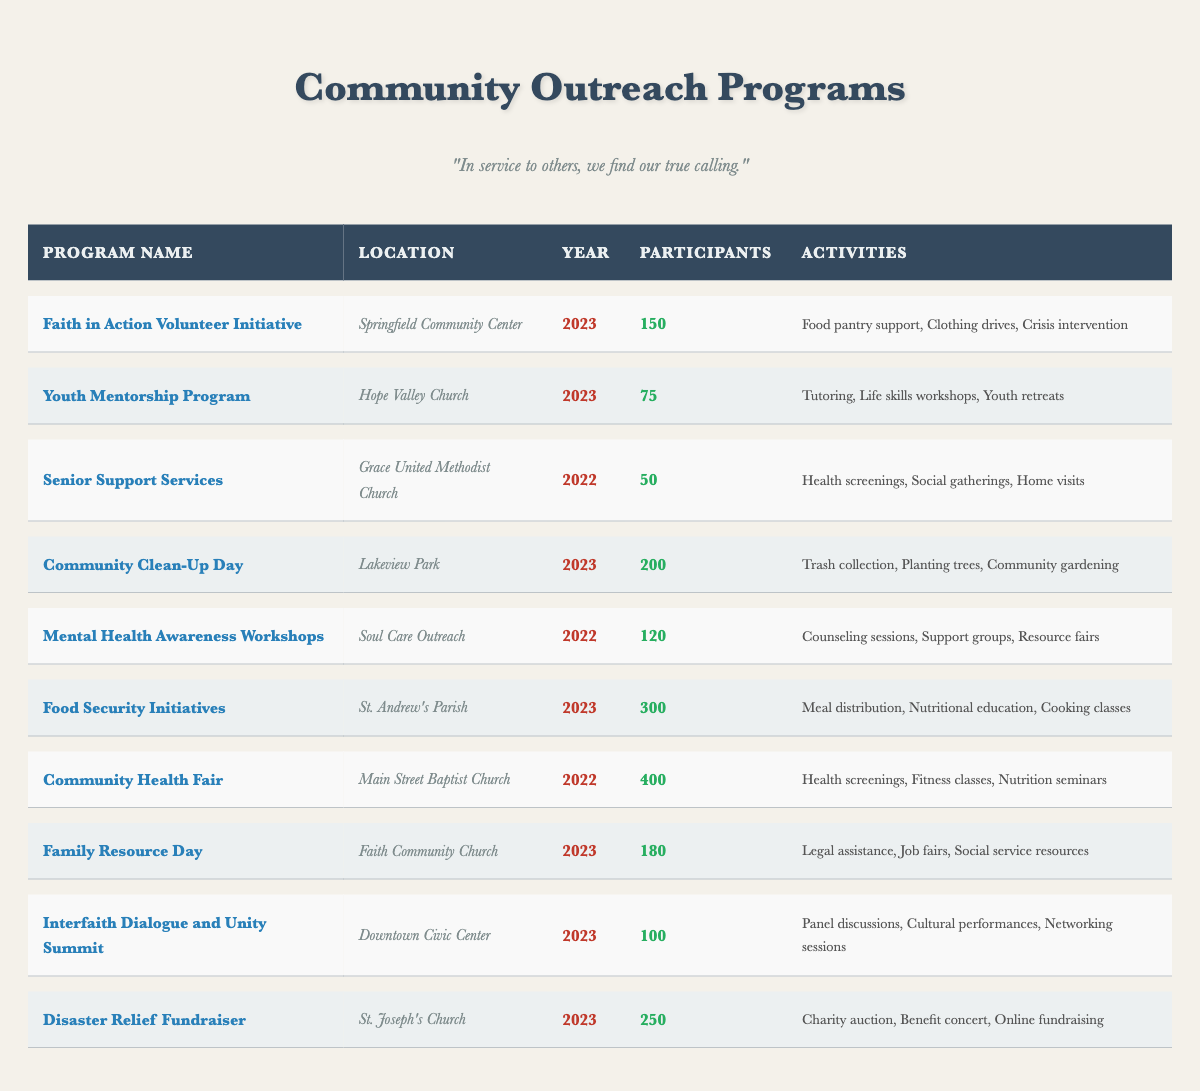What is the most participated outreach program in 2023? By examining the participants column for the year 2023, the program "Food Security Initiatives" has the highest number of participants at 300.
Answer: Food Security Initiatives How many outreach programs took place in 2022? A quick glance at the year column shows there are two programs listed for 2022: "Senior Support Services" and "Community Health Fair".
Answer: 2 What is the total number of participants across all programs in 2023? Summing up the participants from the 2023 programs: 150 (Faith in Action) + 75 (Youth Mentorship) + 200 (Community Clean-Up) + 300 (Food Security) + 180 (Family Resource Day) + 100 (Interfaith Dialogue) + 250 (Disaster Relief) equals 1255 total participants.
Answer: 1255 Did the "Community Health Fair" occur in 2023? Checking the year column for "Community Health Fair", I see it is listed under 2022, confirming it did not occur in 2023.
Answer: No Which program involved the least number of participants in 2022? The program "Senior Support Services" in 2022 had only 50 participants, making it the lowest for that year.
Answer: Senior Support Services What is the average number of participants for outreach programs in 2023? Summing the participants for 2023 programs gives: 150 + 75 + 200 + 300 + 180 + 100 + 250 = 1255. There are 7 programs, so the average is 1255 divided by 7, which equals approximately 179.3.
Answer: 179.3 How many programs focused on mental health awareness in 2022? Reviewing the table, I find that only one program, "Mental Health Awareness Workshops", is dedicated to mental health awareness in 2022.
Answer: 1 What is the total number of activities listed for the "Faith in Action Volunteer Initiative"? The number of activities in the "Faith in Action Volunteer Initiative" includes three: "Food pantry support", "Clothing drives", and "Crisis intervention".
Answer: 3 Which program held the highest number of participants and what location was it in? The program "Community Health Fair" had the highest number of participants at 400 and took place at "Main Street Baptist Church".
Answer: Community Health Fair at Main Street Baptist Church What is the difference in the number of participants between the "Food Security Initiatives" and "Youth Mentorship Program"? The participants for "Food Security Initiatives" is 300 and for "Youth Mentorship Program" it is 75. The difference is 300 - 75 = 225.
Answer: 225 Which outreach program had participants greater than 100 in 2023? The programs with more than 100 participants in 2023 are: "Food Security Initiatives" (300), "Disaster Relief Fundraiser" (250), "Community Clean-Up Day" (200), and "Family Resource Day" (180), making a total of 4 programs.
Answer: 4 